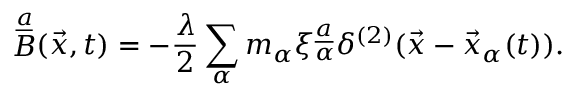Convert formula to latex. <formula><loc_0><loc_0><loc_500><loc_500>B ^ { \underline { a } } ( \vec { x } , t ) = - { \frac { \lambda } { 2 } } \sum _ { \alpha } m _ { \alpha } \xi _ { \alpha } ^ { \underline { a } } \delta ^ { ( 2 ) } ( \vec { x } - \vec { x } _ { \alpha } ( t ) ) .</formula> 